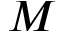Convert formula to latex. <formula><loc_0><loc_0><loc_500><loc_500>M</formula> 